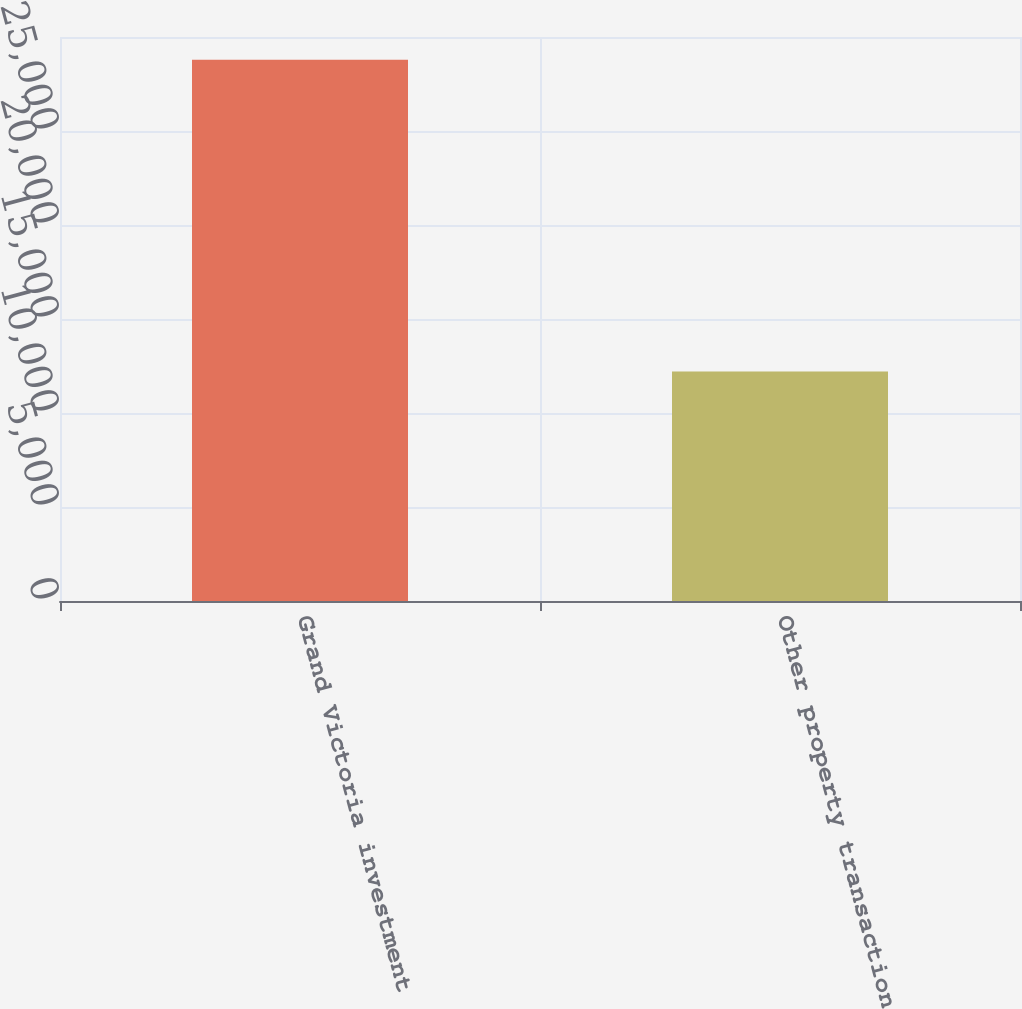Convert chart. <chart><loc_0><loc_0><loc_500><loc_500><bar_chart><fcel>Grand Victoria investment<fcel>Other property transactions<nl><fcel>28789<fcel>12213<nl></chart> 